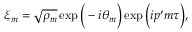<formula> <loc_0><loc_0><loc_500><loc_500>\xi _ { m } = \sqrt { \rho _ { m } } \exp \left ( - i \theta _ { m } \right ) \exp \left ( i p ^ { \prime } m \tau \right ) ,</formula> 